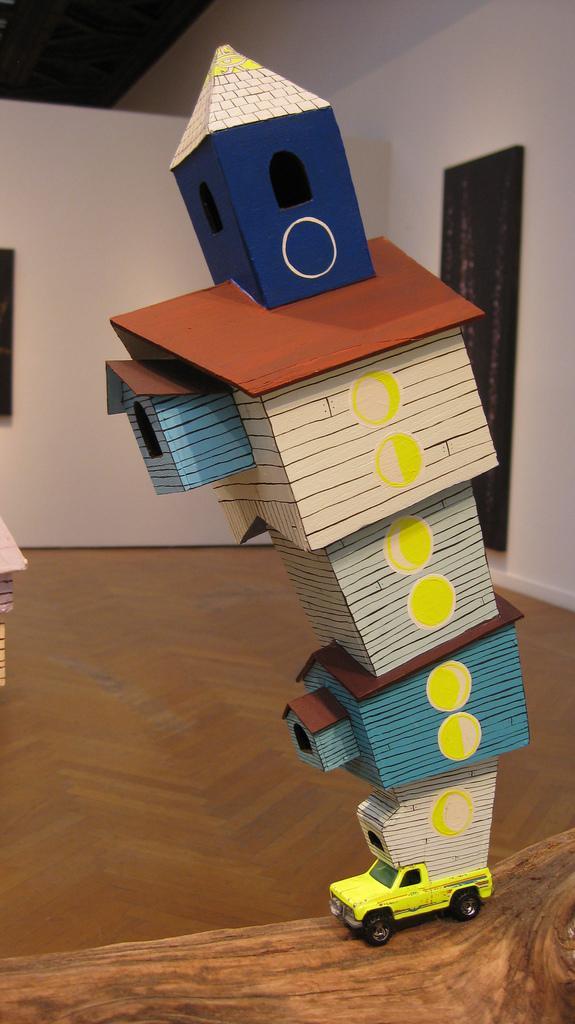Can you describe this image briefly? In this picture we can see toy jeep on the floor and luggage of the jeep which it is carrying his house with windows and in the background we can see wall, frame. 